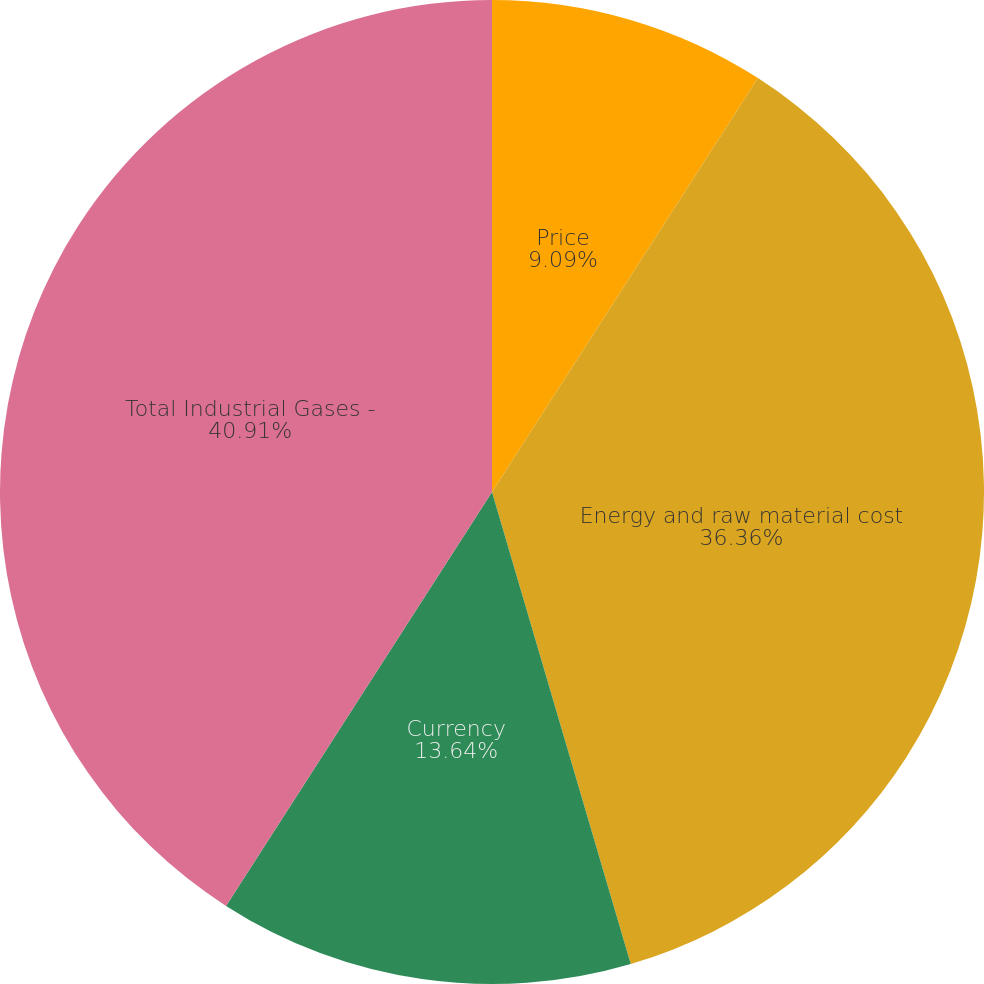Convert chart to OTSL. <chart><loc_0><loc_0><loc_500><loc_500><pie_chart><fcel>Price<fcel>Energy and raw material cost<fcel>Currency<fcel>Total Industrial Gases -<nl><fcel>9.09%<fcel>36.36%<fcel>13.64%<fcel>40.91%<nl></chart> 